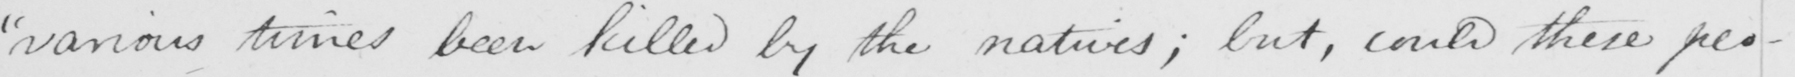What is written in this line of handwriting? " various times been killed by the natives ; but , could these peo- 